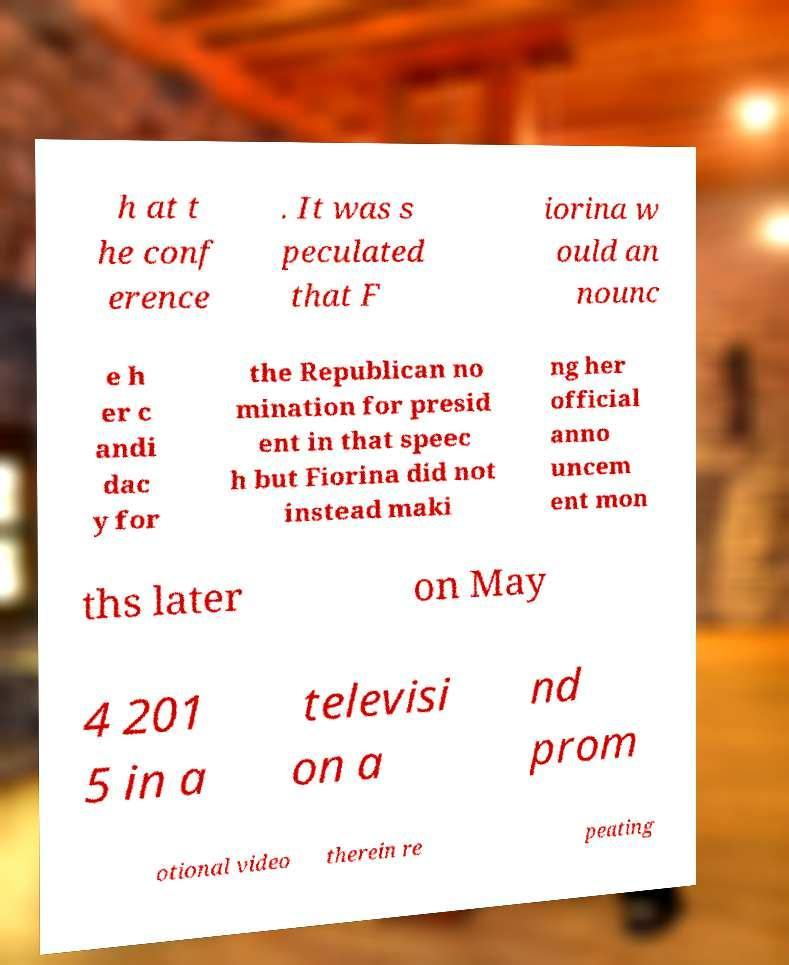Can you accurately transcribe the text from the provided image for me? h at t he conf erence . It was s peculated that F iorina w ould an nounc e h er c andi dac y for the Republican no mination for presid ent in that speec h but Fiorina did not instead maki ng her official anno uncem ent mon ths later on May 4 201 5 in a televisi on a nd prom otional video therein re peating 